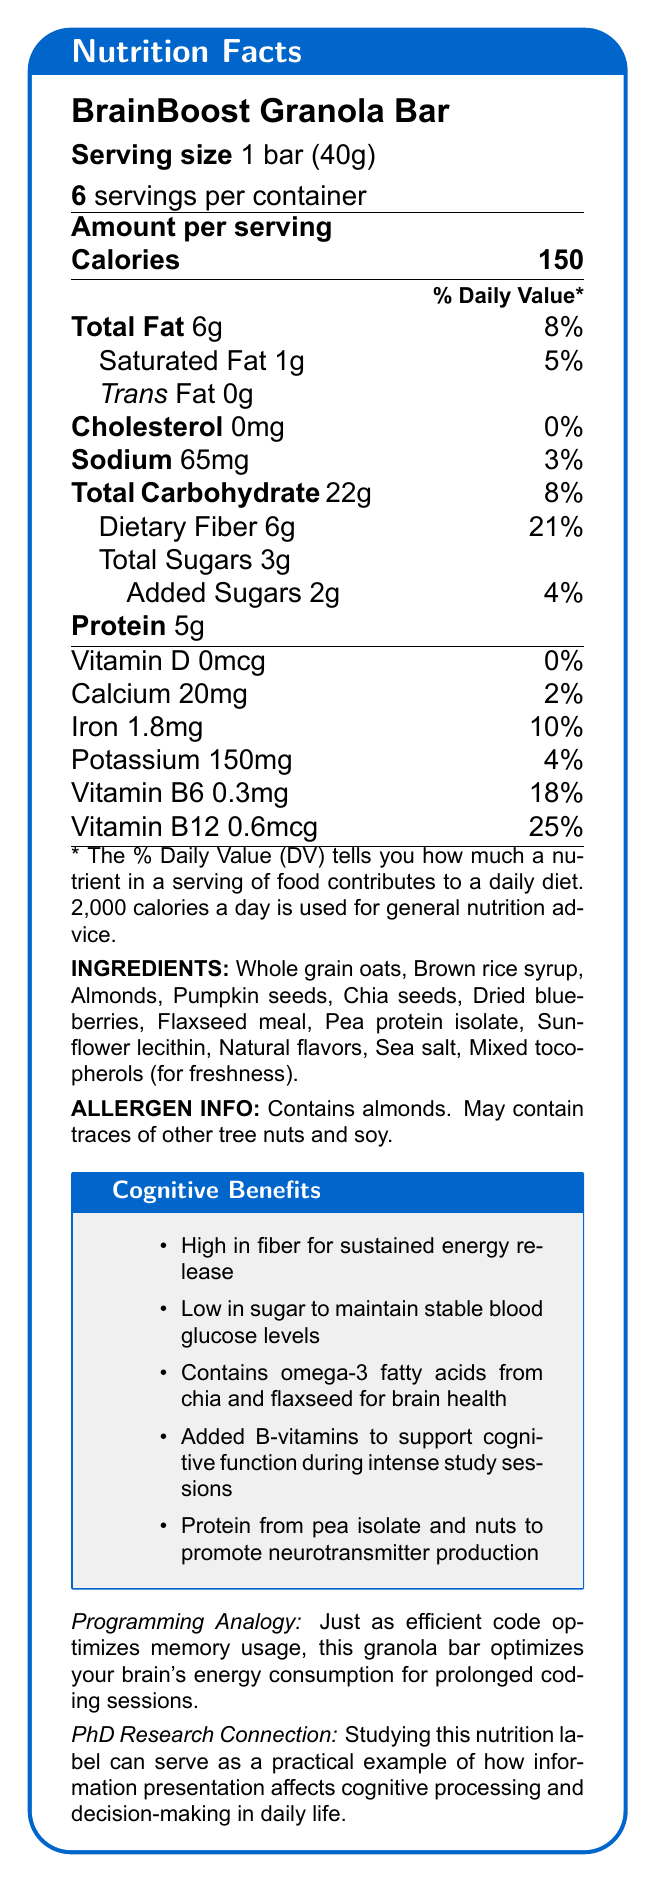What is the serving size of the BrainBoost Granola Bar? The document states "Serving size 1 bar (40g)" near the top underneath the product name.
Answer: 1 bar (40g) How many calories are in one serving? The document indicates "Calories 150" in the Amount per serving section.
Answer: 150 What is the total amount of dietary fiber per serving? The document lists "Dietary Fiber 6g" under Total Carbohydrate.
Answer: 6g List two ingredients found in the granola bar. The ingredients section lists, among others, "Whole grain oats" and "Dried blueberries."
Answer: Whole grain oats, Dried blueberries How much Vitamin B12 is in one serving? The document shows "Vitamin B12 0.6mcg" in the vitamin and mineral content section.
Answer: 0.6mcg Which of the following is NOT listed as an ingredient in the granola bar? A. Almonds B. Pea protein isolate C. High-fructose corn syrup D. Chia seeds High-fructose corn syrup is not listed in the ingredient section, while the others are.
Answer: C What are the cognitive benefits of the BrainBoost Granola Bar? A. High in protein for muscle gain B. Low in sugar to maintain stable blood glucose levels C. Contains omega-3 fatty acids for brain health D. Both B and C The cognitive benefits section lists both "Low in sugar to maintain stable blood glucose levels" and "Contains omega-3 fatty acids from chia and flaxseed for brain health".
Answer: D Does the granola bar contain any allergens? The allergen info section states, "Contains almonds. May contain traces of other tree nuts and soy.”
Answer: Yes Summarize the main idea of the document. The document provides nutrition facts, ingredient information, potential allergens, cognitive benefits, and even a programming analogy to explain how this granola bar helps optimize brain energy consumption.
Answer: The BrainBoost Granola Bar is a low-sugar, high-fiber snack designed to promote sustained mental focus through cognitive benefits such as stable blood glucose levels, omega-3 fatty acids, and added B-vitamins. Who is the manufacturer of the BrainBoost Granola Bar? The document does not provide any details about the manufacturer of the BrainBoost Granola Bar.
Answer: Not enough information 